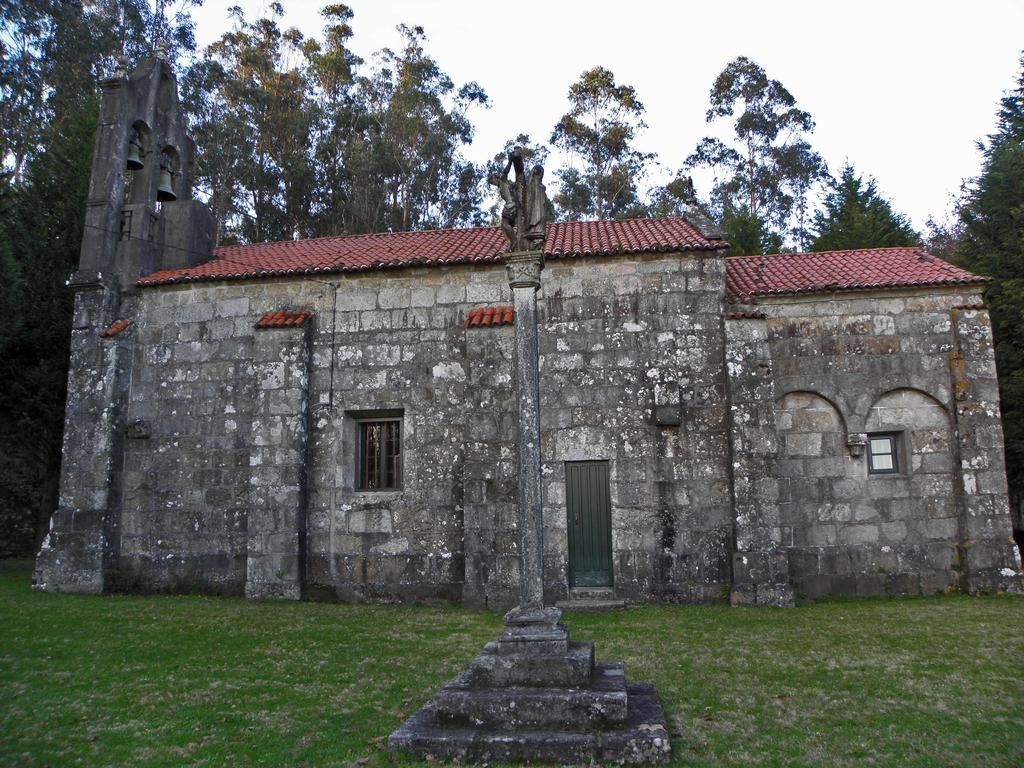Please provide a concise description of this image. This is a building with the windows and a door. Here is the grass. I think these are the sculptures, which are at the top of a pillar. In the background, I can see the trees with branches and leaves. This is the sky. 